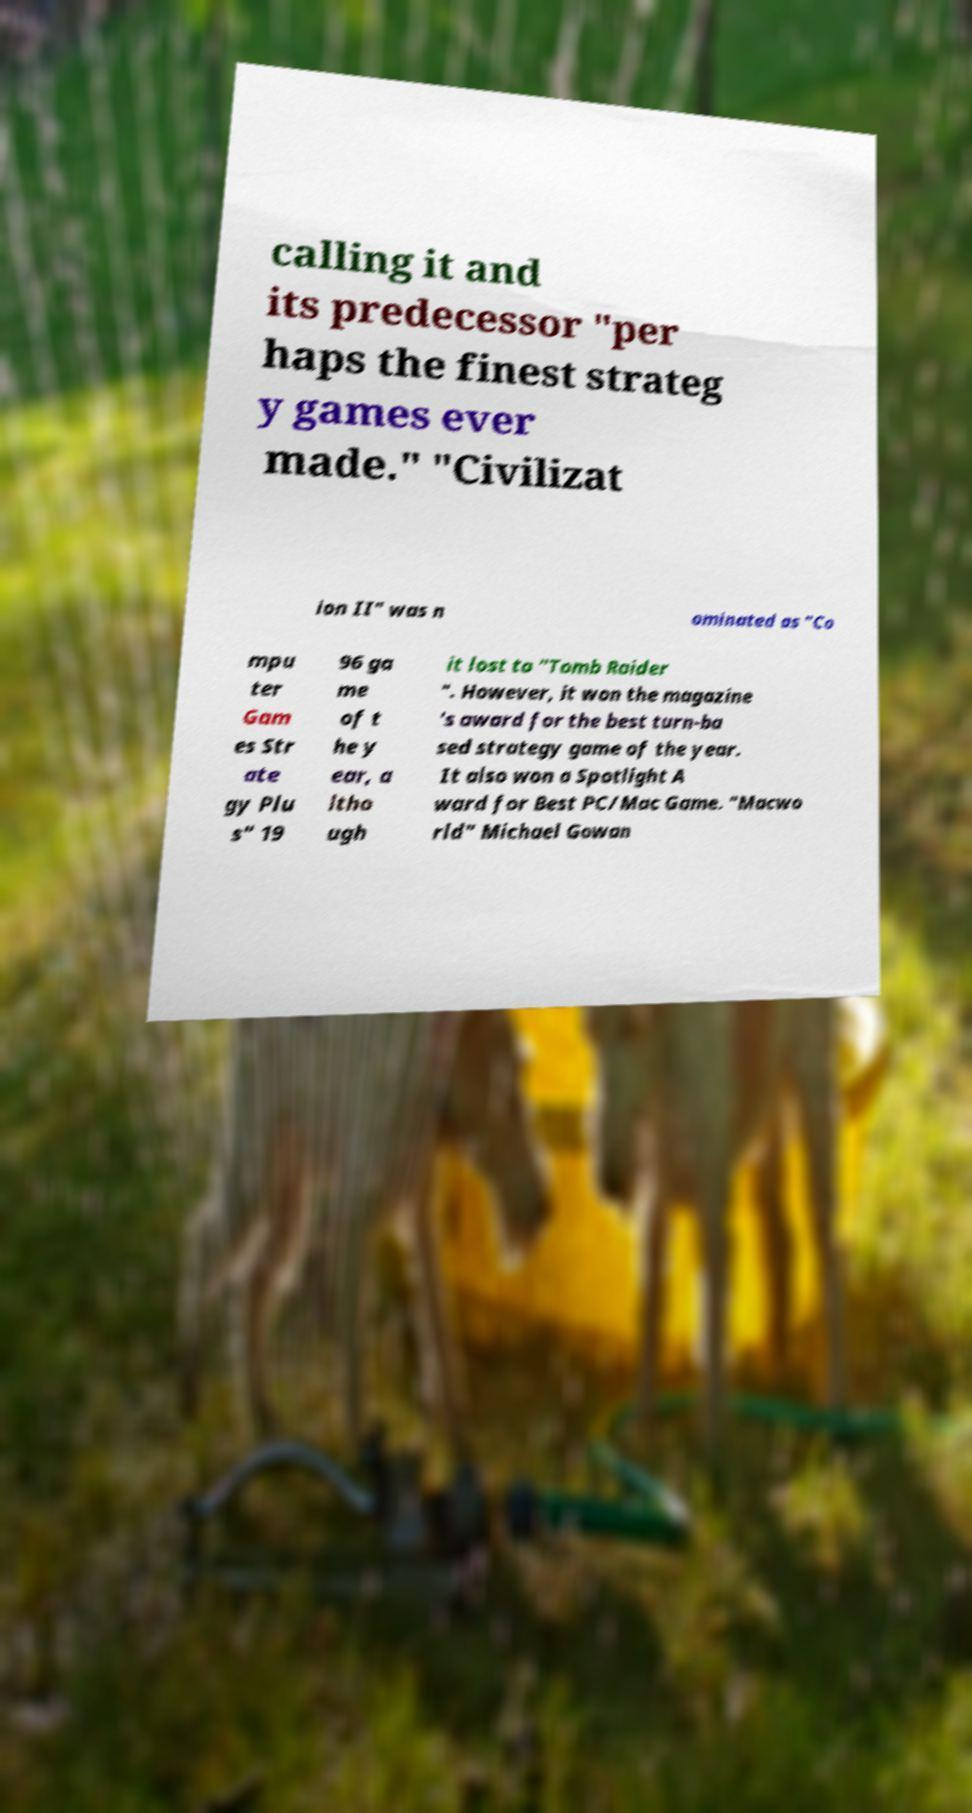What messages or text are displayed in this image? I need them in a readable, typed format. calling it and its predecessor "per haps the finest strateg y games ever made." "Civilizat ion II" was n ominated as "Co mpu ter Gam es Str ate gy Plu s" 19 96 ga me of t he y ear, a ltho ugh it lost to "Tomb Raider ". However, it won the magazine 's award for the best turn-ba sed strategy game of the year. It also won a Spotlight A ward for Best PC/Mac Game. "Macwo rld" Michael Gowan 